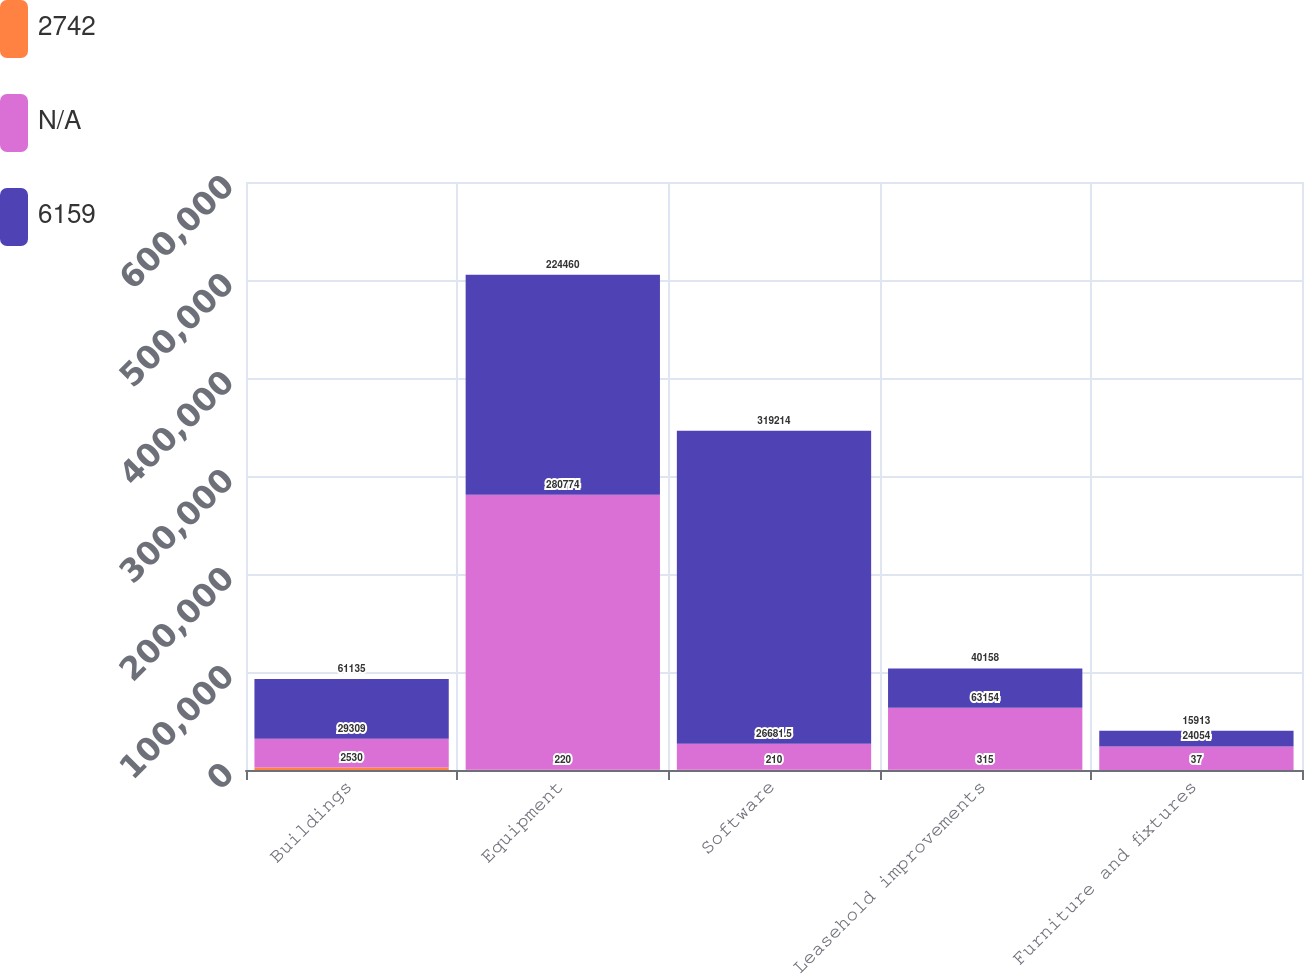Convert chart. <chart><loc_0><loc_0><loc_500><loc_500><stacked_bar_chart><ecel><fcel>Buildings<fcel>Equipment<fcel>Software<fcel>Leasehold improvements<fcel>Furniture and fixtures<nl><fcel>2742<fcel>2530<fcel>220<fcel>210<fcel>315<fcel>37<nl><fcel>nan<fcel>29309<fcel>280774<fcel>26681.5<fcel>63154<fcel>24054<nl><fcel>6159<fcel>61135<fcel>224460<fcel>319214<fcel>40158<fcel>15913<nl></chart> 